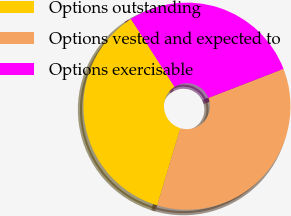Convert chart. <chart><loc_0><loc_0><loc_500><loc_500><pie_chart><fcel>Options outstanding<fcel>Options vested and expected to<fcel>Options exercisable<nl><fcel>36.29%<fcel>35.51%<fcel>28.2%<nl></chart> 